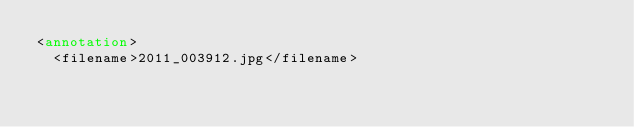<code> <loc_0><loc_0><loc_500><loc_500><_XML_><annotation>
	<filename>2011_003912.jpg</filename></code> 